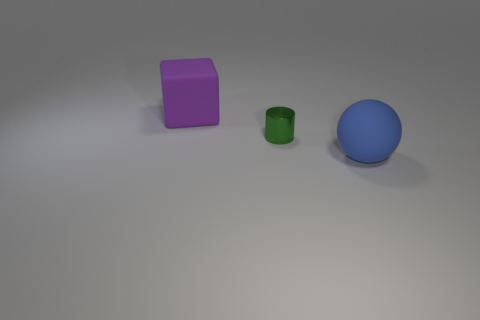There is a small thing; are there any cylinders on the right side of it?
Provide a short and direct response. No. There is a purple matte cube; is it the same size as the matte object right of the tiny green metal cylinder?
Your answer should be compact. Yes. The large thing that is in front of the matte object to the left of the large blue matte thing is what color?
Keep it short and to the point. Blue. Is the size of the metallic object the same as the block?
Keep it short and to the point. No. What is the size of the ball?
Make the answer very short. Large. Does the matte object behind the big blue rubber object have the same color as the rubber ball?
Offer a terse response. No. Are there more large matte balls that are in front of the large matte ball than large blue rubber balls that are to the right of the green metallic cylinder?
Provide a succinct answer. No. Is the number of small metallic cylinders greater than the number of red matte cylinders?
Make the answer very short. Yes. How big is the thing that is left of the rubber ball and in front of the large purple thing?
Your answer should be very brief. Small. The big blue object is what shape?
Provide a succinct answer. Sphere. 